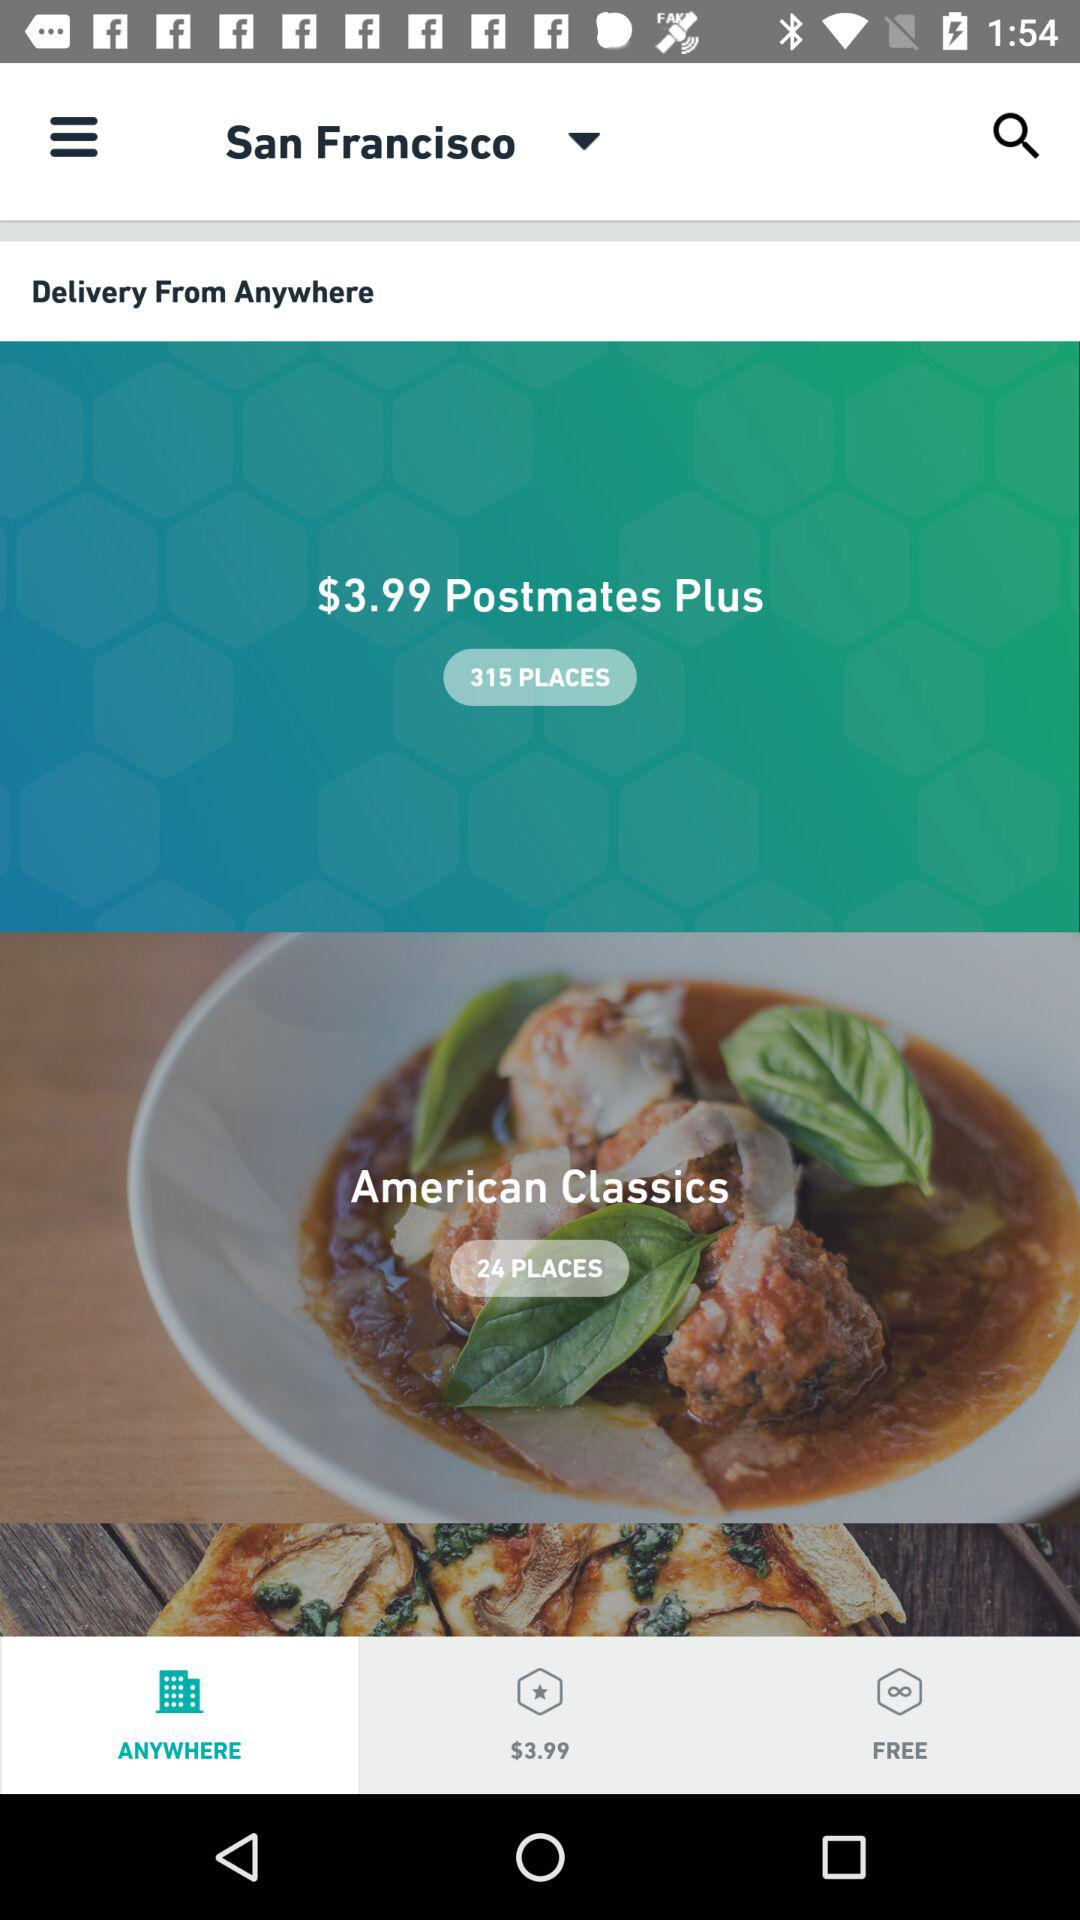How many more places are available with Postmates Plus than with American Classics?
Answer the question using a single word or phrase. 291 